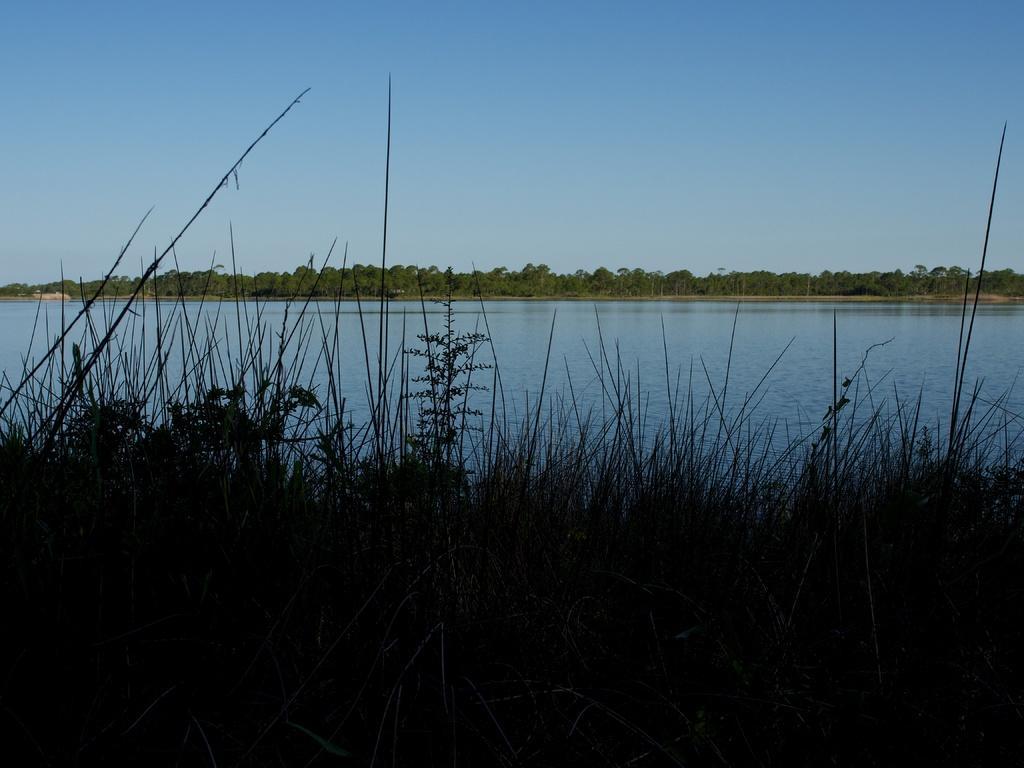Please provide a concise description of this image. This is a picture of a lake. Far there are trees in green color. Sky is in blue color. Water looks fresh. These are plants. 